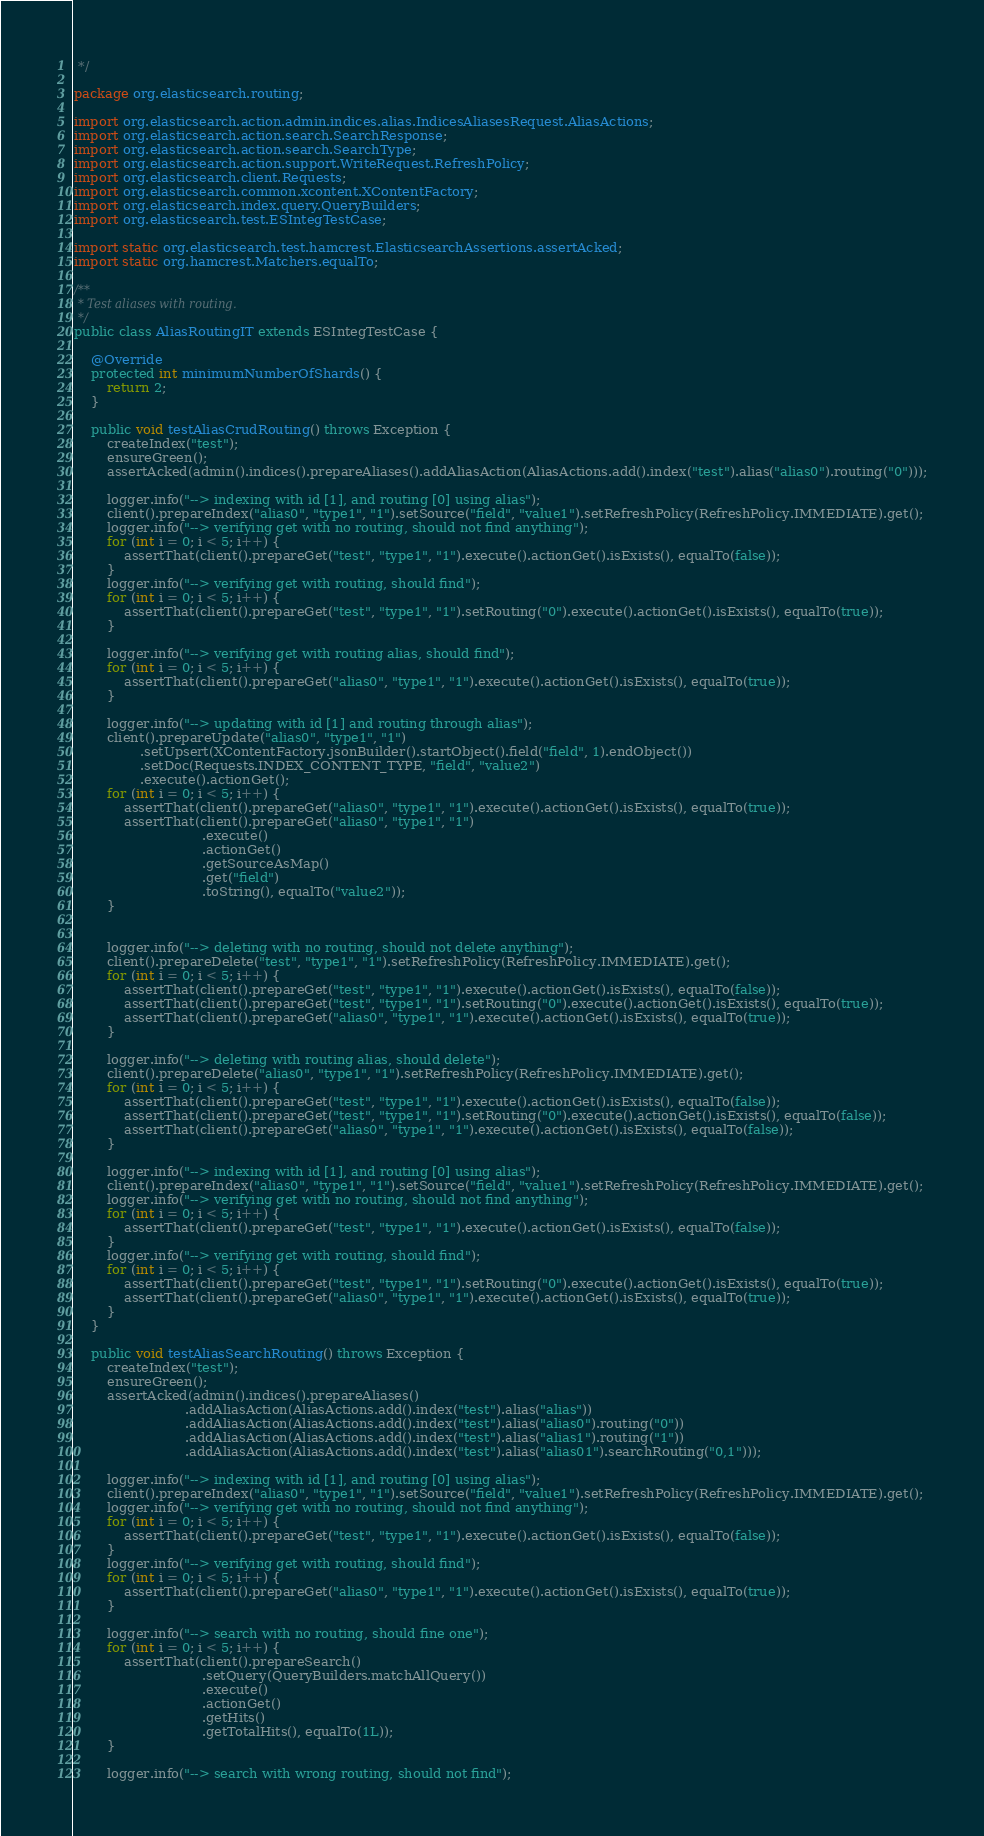<code> <loc_0><loc_0><loc_500><loc_500><_Java_> */

package org.elasticsearch.routing;

import org.elasticsearch.action.admin.indices.alias.IndicesAliasesRequest.AliasActions;
import org.elasticsearch.action.search.SearchResponse;
import org.elasticsearch.action.search.SearchType;
import org.elasticsearch.action.support.WriteRequest.RefreshPolicy;
import org.elasticsearch.client.Requests;
import org.elasticsearch.common.xcontent.XContentFactory;
import org.elasticsearch.index.query.QueryBuilders;
import org.elasticsearch.test.ESIntegTestCase;

import static org.elasticsearch.test.hamcrest.ElasticsearchAssertions.assertAcked;
import static org.hamcrest.Matchers.equalTo;

/**
 * Test aliases with routing.
 */
public class AliasRoutingIT extends ESIntegTestCase {

    @Override
    protected int minimumNumberOfShards() {
        return 2;
    }

    public void testAliasCrudRouting() throws Exception {
        createIndex("test");
        ensureGreen();
        assertAcked(admin().indices().prepareAliases().addAliasAction(AliasActions.add().index("test").alias("alias0").routing("0")));

        logger.info("--> indexing with id [1], and routing [0] using alias");
        client().prepareIndex("alias0", "type1", "1").setSource("field", "value1").setRefreshPolicy(RefreshPolicy.IMMEDIATE).get();
        logger.info("--> verifying get with no routing, should not find anything");
        for (int i = 0; i < 5; i++) {
            assertThat(client().prepareGet("test", "type1", "1").execute().actionGet().isExists(), equalTo(false));
        }
        logger.info("--> verifying get with routing, should find");
        for (int i = 0; i < 5; i++) {
            assertThat(client().prepareGet("test", "type1", "1").setRouting("0").execute().actionGet().isExists(), equalTo(true));
        }

        logger.info("--> verifying get with routing alias, should find");
        for (int i = 0; i < 5; i++) {
            assertThat(client().prepareGet("alias0", "type1", "1").execute().actionGet().isExists(), equalTo(true));
        }

        logger.info("--> updating with id [1] and routing through alias");
        client().prepareUpdate("alias0", "type1", "1")
                .setUpsert(XContentFactory.jsonBuilder().startObject().field("field", 1).endObject())
                .setDoc(Requests.INDEX_CONTENT_TYPE, "field", "value2")
                .execute().actionGet();
        for (int i = 0; i < 5; i++) {
            assertThat(client().prepareGet("alias0", "type1", "1").execute().actionGet().isExists(), equalTo(true));
            assertThat(client().prepareGet("alias0", "type1", "1")
                               .execute()
                               .actionGet()
                               .getSourceAsMap()
                               .get("field")
                               .toString(), equalTo("value2"));
        }


        logger.info("--> deleting with no routing, should not delete anything");
        client().prepareDelete("test", "type1", "1").setRefreshPolicy(RefreshPolicy.IMMEDIATE).get();
        for (int i = 0; i < 5; i++) {
            assertThat(client().prepareGet("test", "type1", "1").execute().actionGet().isExists(), equalTo(false));
            assertThat(client().prepareGet("test", "type1", "1").setRouting("0").execute().actionGet().isExists(), equalTo(true));
            assertThat(client().prepareGet("alias0", "type1", "1").execute().actionGet().isExists(), equalTo(true));
        }

        logger.info("--> deleting with routing alias, should delete");
        client().prepareDelete("alias0", "type1", "1").setRefreshPolicy(RefreshPolicy.IMMEDIATE).get();
        for (int i = 0; i < 5; i++) {
            assertThat(client().prepareGet("test", "type1", "1").execute().actionGet().isExists(), equalTo(false));
            assertThat(client().prepareGet("test", "type1", "1").setRouting("0").execute().actionGet().isExists(), equalTo(false));
            assertThat(client().prepareGet("alias0", "type1", "1").execute().actionGet().isExists(), equalTo(false));
        }

        logger.info("--> indexing with id [1], and routing [0] using alias");
        client().prepareIndex("alias0", "type1", "1").setSource("field", "value1").setRefreshPolicy(RefreshPolicy.IMMEDIATE).get();
        logger.info("--> verifying get with no routing, should not find anything");
        for (int i = 0; i < 5; i++) {
            assertThat(client().prepareGet("test", "type1", "1").execute().actionGet().isExists(), equalTo(false));
        }
        logger.info("--> verifying get with routing, should find");
        for (int i = 0; i < 5; i++) {
            assertThat(client().prepareGet("test", "type1", "1").setRouting("0").execute().actionGet().isExists(), equalTo(true));
            assertThat(client().prepareGet("alias0", "type1", "1").execute().actionGet().isExists(), equalTo(true));
        }
    }

    public void testAliasSearchRouting() throws Exception {
        createIndex("test");
        ensureGreen();
        assertAcked(admin().indices().prepareAliases()
                           .addAliasAction(AliasActions.add().index("test").alias("alias"))
                           .addAliasAction(AliasActions.add().index("test").alias("alias0").routing("0"))
                           .addAliasAction(AliasActions.add().index("test").alias("alias1").routing("1"))
                           .addAliasAction(AliasActions.add().index("test").alias("alias01").searchRouting("0,1")));

        logger.info("--> indexing with id [1], and routing [0] using alias");
        client().prepareIndex("alias0", "type1", "1").setSource("field", "value1").setRefreshPolicy(RefreshPolicy.IMMEDIATE).get();
        logger.info("--> verifying get with no routing, should not find anything");
        for (int i = 0; i < 5; i++) {
            assertThat(client().prepareGet("test", "type1", "1").execute().actionGet().isExists(), equalTo(false));
        }
        logger.info("--> verifying get with routing, should find");
        for (int i = 0; i < 5; i++) {
            assertThat(client().prepareGet("alias0", "type1", "1").execute().actionGet().isExists(), equalTo(true));
        }

        logger.info("--> search with no routing, should fine one");
        for (int i = 0; i < 5; i++) {
            assertThat(client().prepareSearch()
                               .setQuery(QueryBuilders.matchAllQuery())
                               .execute()
                               .actionGet()
                               .getHits()
                               .getTotalHits(), equalTo(1L));
        }

        logger.info("--> search with wrong routing, should not find");</code> 